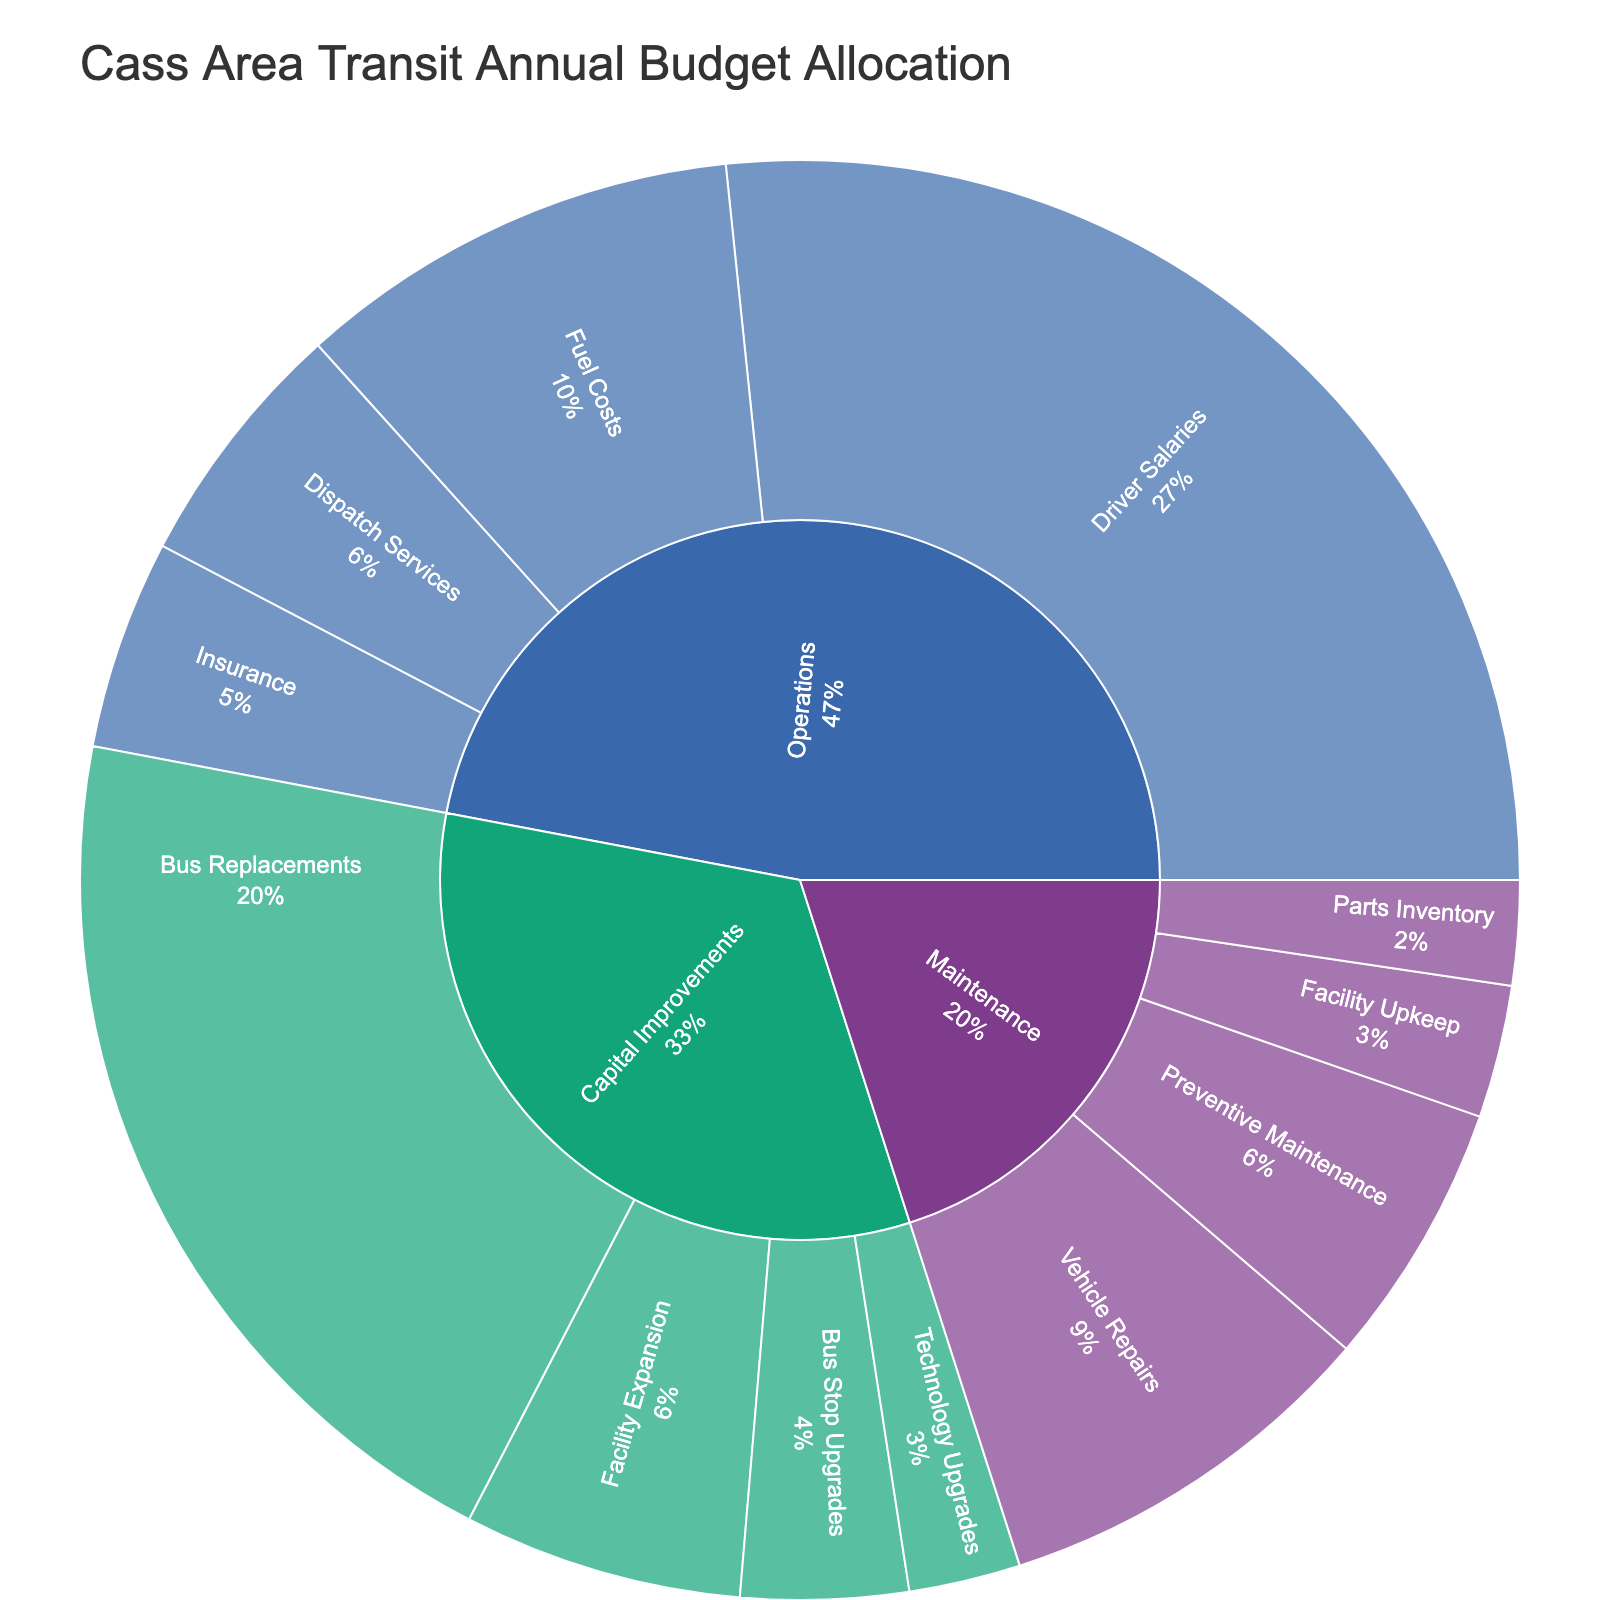What is the title of the figure? The title of the figure is written at the top and states, "Cass Area Transit Annual Budget Allocation". The title typically summarizes the main topic or insight that the plot is meant to convey.
Answer: Cass Area Transit Annual Budget Allocation Which category has the largest allocation? To determine the largest allocation, look at the sizes of the main sections in the sunburst plot. The category 'Operations' takes up the most space, indicating it has the largest budget allocation.
Answer: Operations How much is allocated to Driver Salaries? From the plot, Driver Salaries is a subcategory under Operations. The text information on the plot shows the value allocated to Driver Salaries.
Answer: $850,000 Which subcategory under Capital Improvements has the smallest budget? Looking at the 'Capital Improvements' category, compare the sizes of the subcategories. 'Technology Upgrades' is the smallest subcategory.
Answer: Technology Upgrades How much more is allocated to Bus Replacements compared to Fuel Costs? Bus Replacements has an allocation of $650,000, and Fuel Costs has $320,000. The difference is calculated as $650,000 - $320,000.
Answer: $330,000 What percentage of the total budget is allocated to Maintenance? The plot measures the percentage based on sections. The percentage for 'Maintenance' can be visually interpreted from the chart.
Answer: Approximately 20% Compare the budget allocation for Preventive Maintenance and Vehicle Repairs. Which one is larger? The sizes of the sections for Preventive Maintenance and Vehicle Repairs within the Maintenance category show that Vehicle Repairs has a larger budget.
Answer: Vehicle Repairs What is the total budget allocated to Capital Improvements? Sum up the values of all subcategories under Capital Improvements: Bus Replacements ($650,000), Bus Stop Upgrades ($120,000), Technology Upgrades ($80,000), and Facility Expansion ($200,000). The total is $650,000 + $120,000 + $80,000 + $200,000.
Answer: $1,050,000 Which category has the highest number of subcategories? Count the number of subcategories under each main category in the sunburst plot. Operations, Maintenance, and Capital Improvements have their sections. Operations has the most, with four subcategories.
Answer: Operations What's the total budget for Operations and Maintenance combined? Sum the values of all subcategories under Operations (Driver Salaries $850,000, Fuel Costs $320,000, Dispatch Services $180,000, Insurance $150,000) and Maintenance (Vehicle Repairs $280,000, Preventive Maintenance $190,000, Facility Upkeep $95,000, Parts Inventory $75,000). The total is $1,500,000 + $640,000.
Answer: $2,140,000 